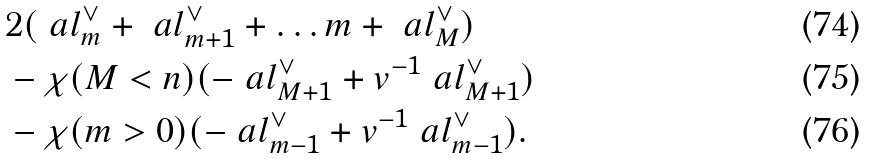<formula> <loc_0><loc_0><loc_500><loc_500>& 2 ( \ a l _ { m } ^ { \vee } + \ a l _ { m + 1 } ^ { \vee } + \dots m + \ a l _ { M } ^ { \vee } ) \\ & - \chi ( M < n ) ( - \ a l _ { M + 1 } ^ { \vee } + v ^ { - 1 } \ a l _ { M + 1 } ^ { \vee } ) \\ & - \chi ( m > 0 ) ( - \ a l _ { m - 1 } ^ { \vee } + v ^ { - 1 } \ a l _ { m - 1 } ^ { \vee } ) .</formula> 